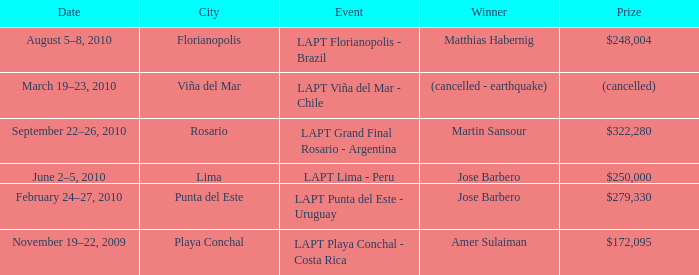What was the specific date of amer sulaiman's triumph? November 19–22, 2009. 